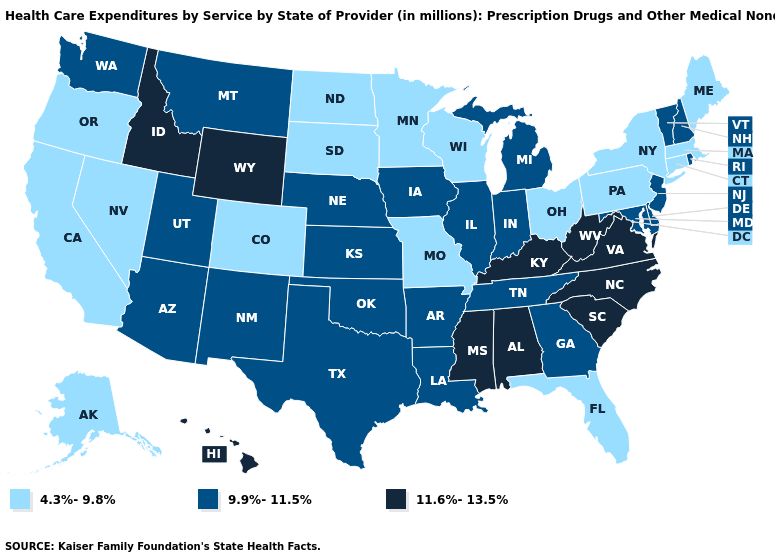What is the highest value in the USA?
Write a very short answer. 11.6%-13.5%. What is the lowest value in the Northeast?
Be succinct. 4.3%-9.8%. Name the states that have a value in the range 11.6%-13.5%?
Quick response, please. Alabama, Hawaii, Idaho, Kentucky, Mississippi, North Carolina, South Carolina, Virginia, West Virginia, Wyoming. Does Washington have a lower value than Indiana?
Give a very brief answer. No. What is the highest value in the Northeast ?
Quick response, please. 9.9%-11.5%. Which states have the lowest value in the USA?
Answer briefly. Alaska, California, Colorado, Connecticut, Florida, Maine, Massachusetts, Minnesota, Missouri, Nevada, New York, North Dakota, Ohio, Oregon, Pennsylvania, South Dakota, Wisconsin. Does Minnesota have the lowest value in the MidWest?
Give a very brief answer. Yes. Which states hav the highest value in the West?
Short answer required. Hawaii, Idaho, Wyoming. Among the states that border Maryland , does Virginia have the highest value?
Answer briefly. Yes. Name the states that have a value in the range 4.3%-9.8%?
Concise answer only. Alaska, California, Colorado, Connecticut, Florida, Maine, Massachusetts, Minnesota, Missouri, Nevada, New York, North Dakota, Ohio, Oregon, Pennsylvania, South Dakota, Wisconsin. What is the lowest value in the West?
Be succinct. 4.3%-9.8%. What is the highest value in the West ?
Keep it brief. 11.6%-13.5%. Does the map have missing data?
Short answer required. No. Does Wyoming have the highest value in the USA?
Quick response, please. Yes. What is the highest value in the USA?
Quick response, please. 11.6%-13.5%. 